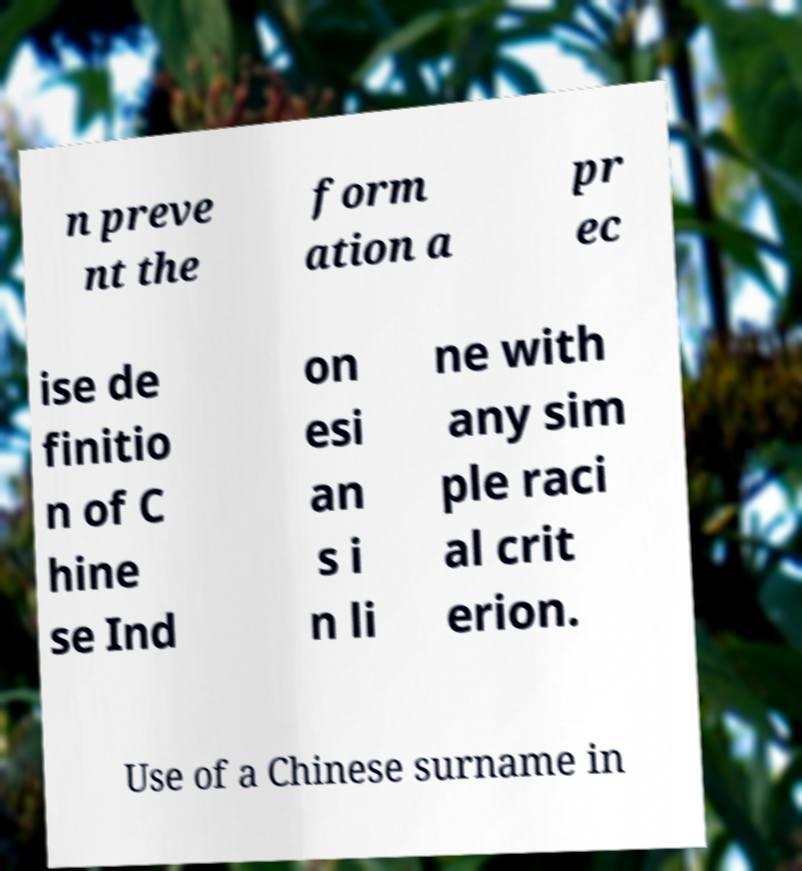Could you extract and type out the text from this image? n preve nt the form ation a pr ec ise de finitio n of C hine se Ind on esi an s i n li ne with any sim ple raci al crit erion. Use of a Chinese surname in 